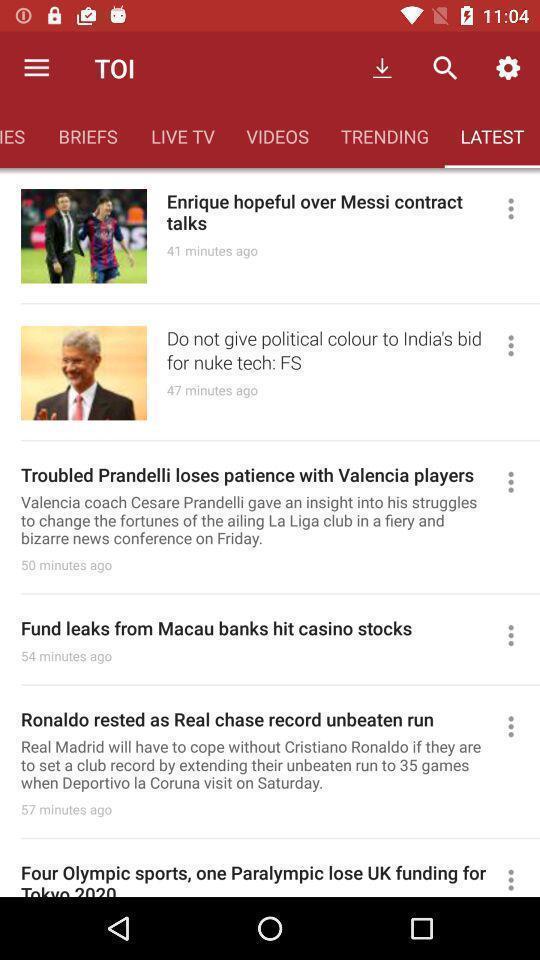What is the overall content of this screenshot? Screen displaying multiple latest news articles information. 